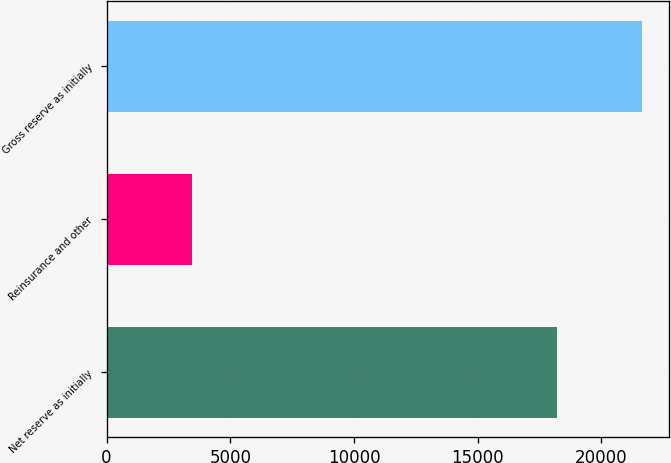<chart> <loc_0><loc_0><loc_500><loc_500><bar_chart><fcel>Net reserve as initially<fcel>Reinsurance and other<fcel>Gross reserve as initially<nl><fcel>18210<fcel>3441<fcel>21651<nl></chart> 